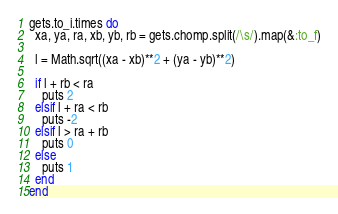<code> <loc_0><loc_0><loc_500><loc_500><_Ruby_>gets.to_i.times do
  xa, ya, ra, xb, yb, rb = gets.chomp.split(/\s/).map(&:to_f)

  l = Math.sqrt((xa - xb)**2 + (ya - yb)**2)

  if l + rb < ra
    puts 2
  elsif l + ra < rb
    puts -2
  elsif l > ra + rb
    puts 0
  else
    puts 1
  end
end</code> 